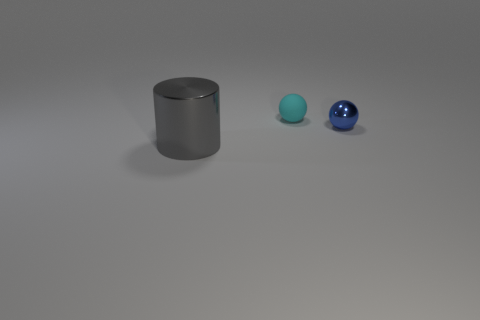Reflect on the size comparison between the objects, would you say there's any significance to their scale? The differences in size among the three spheres—as well as their different distances from the viewer—could be implying depth and perspective. The varying sizes create a visual hierarchy and might symbolize differing levels of importance or influence if one were to interpret the scene metaphorically. 